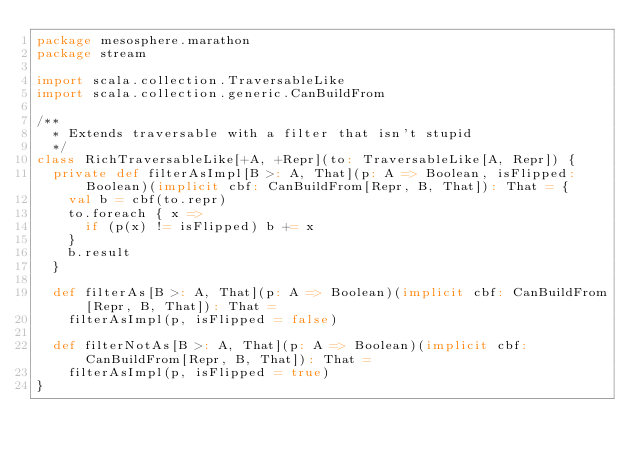<code> <loc_0><loc_0><loc_500><loc_500><_Scala_>package mesosphere.marathon
package stream

import scala.collection.TraversableLike
import scala.collection.generic.CanBuildFrom

/**
  * Extends traversable with a filter that isn't stupid
  */
class RichTraversableLike[+A, +Repr](to: TraversableLike[A, Repr]) {
  private def filterAsImpl[B >: A, That](p: A => Boolean, isFlipped: Boolean)(implicit cbf: CanBuildFrom[Repr, B, That]): That = {
    val b = cbf(to.repr)
    to.foreach { x =>
      if (p(x) != isFlipped) b += x
    }
    b.result
  }

  def filterAs[B >: A, That](p: A => Boolean)(implicit cbf: CanBuildFrom[Repr, B, That]): That =
    filterAsImpl(p, isFlipped = false)

  def filterNotAs[B >: A, That](p: A => Boolean)(implicit cbf: CanBuildFrom[Repr, B, That]): That =
    filterAsImpl(p, isFlipped = true)
}
</code> 